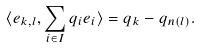Convert formula to latex. <formula><loc_0><loc_0><loc_500><loc_500>\langle e _ { k , l } , \sum _ { i \in I } q _ { i } e _ { i } \rangle = q _ { k } - q _ { n ( l ) } .</formula> 